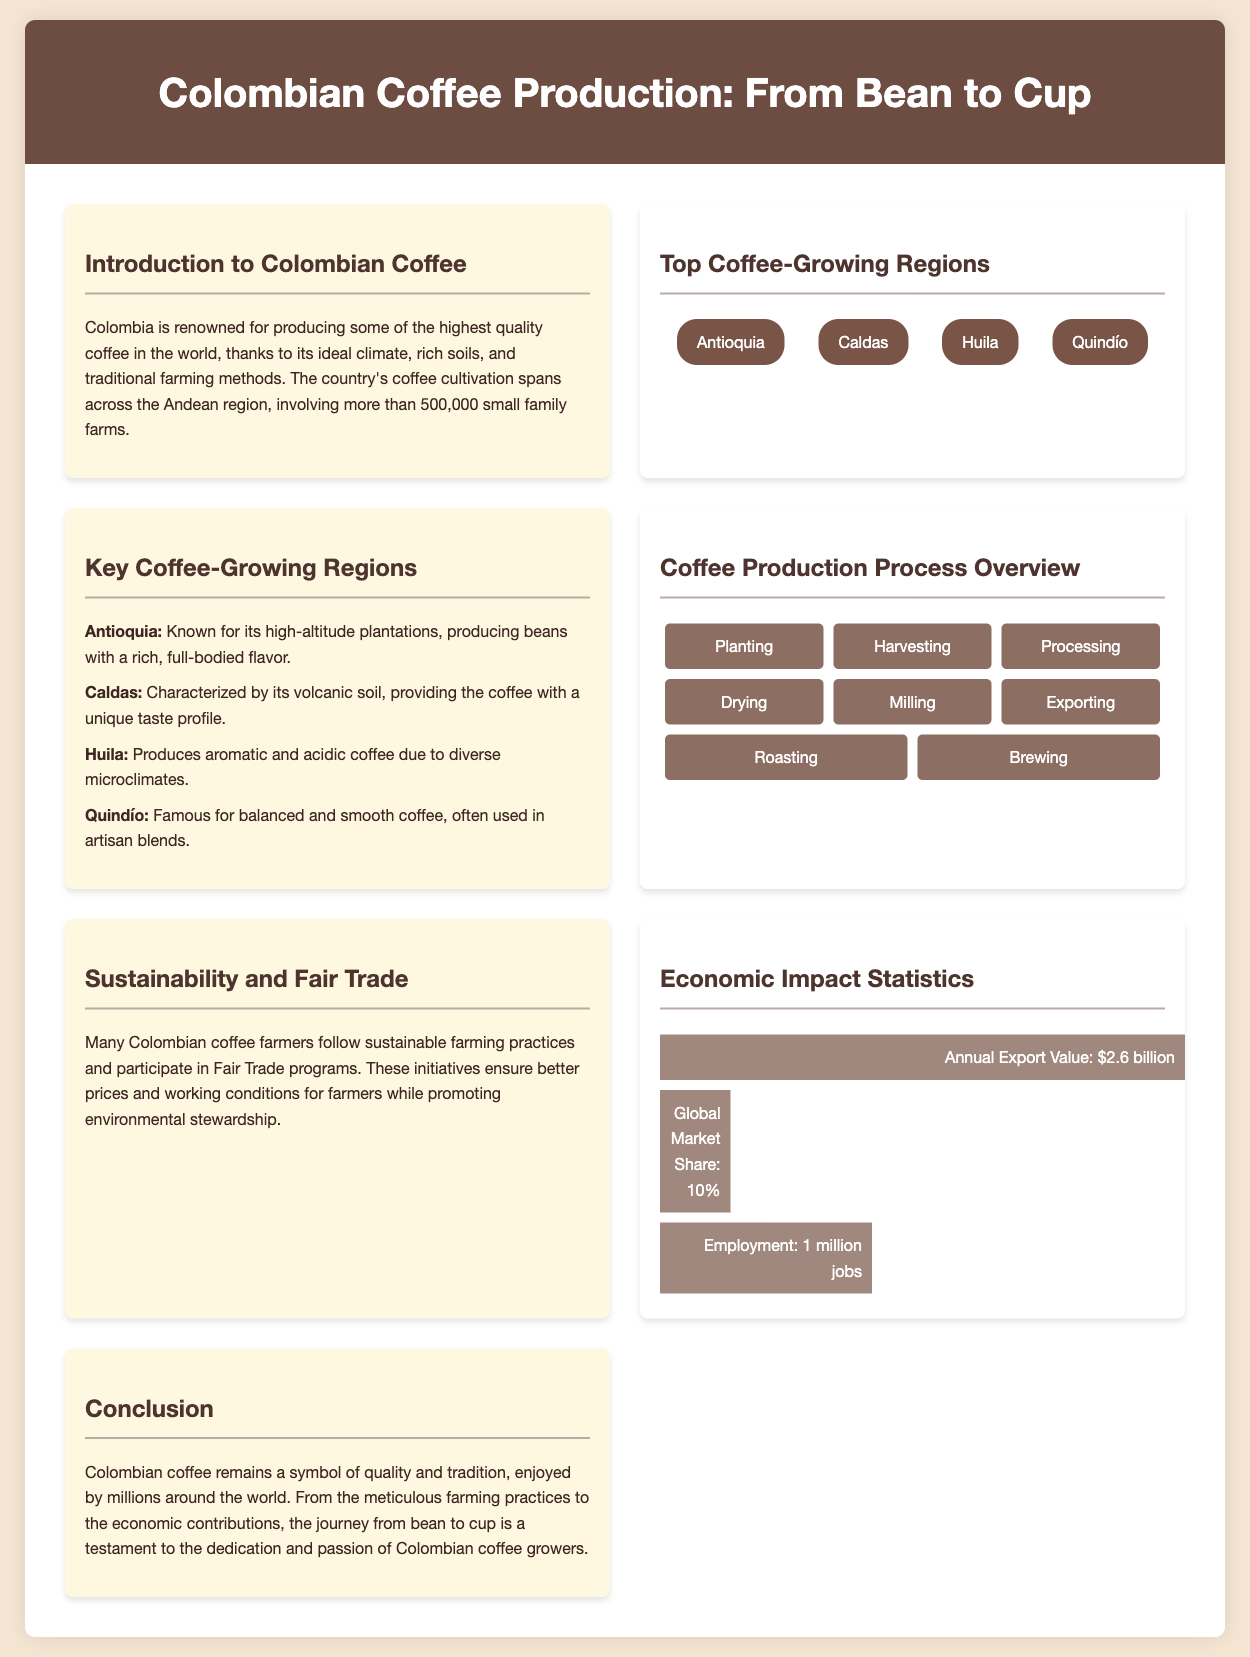what is the annual export value of Colombian coffee? The annual export value is stated in the "Economic Impact Statistics" section of the document.
Answer: $2.6 billion which region is known for high-altitude plantations? The "Key Coffee-Growing Regions" section lists regions and describes their characteristics.
Answer: Antioquia how many jobs are associated with the coffee industry in Colombia? The document specifies the number of jobs stated in the "Economic Impact Statistics" section.
Answer: 1 million jobs what process comes after drying in coffee production? The "Coffee Production Process Overview" section lists the steps in the coffee production process.
Answer: Milling what percentage of the global market share does Colombian coffee hold? The document provides this information under "Economic Impact Statistics."
Answer: 10% which coffee-growing region is famous for balanced and smooth coffee? The "Key Coffee-Growing Regions" section indicates the characteristics of various regions.
Answer: Quindío how many coffee-growing regions are displayed on the map? The map in the "Top Coffee-Growing Regions" section illustrates the major coffee-growing regions in Colombia.
Answer: 4 which step in the coffee production process involves making coffee ready for sale? The document describes each step of the coffee production process, which includes this aspect.
Answer: Exporting 